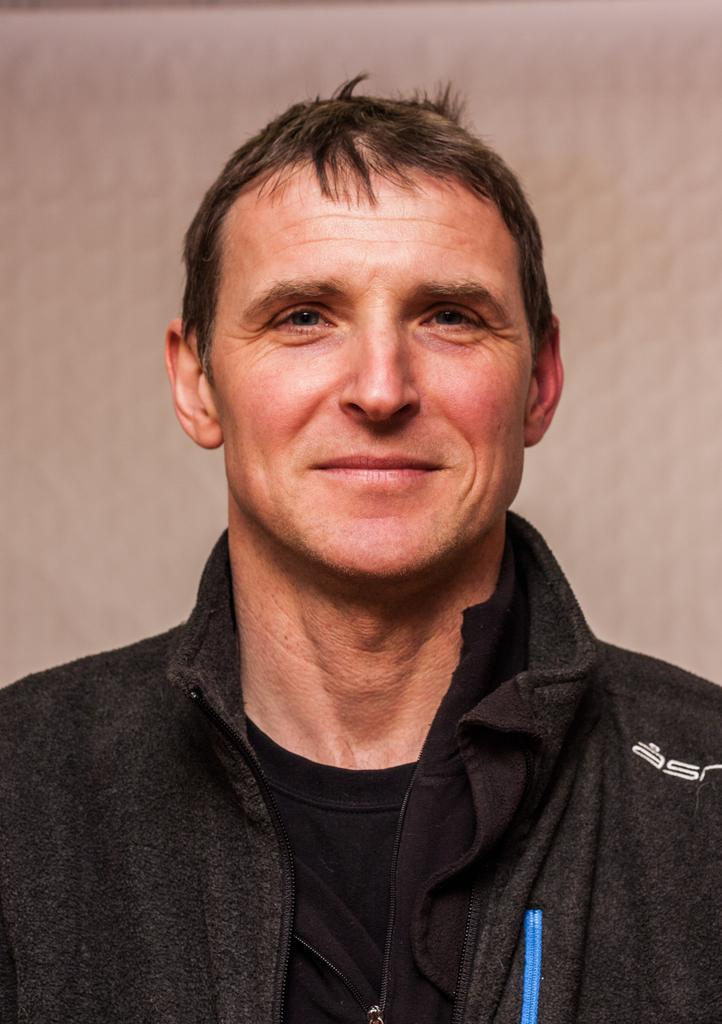Who is present in the image? There is a man in the picture. What is the man wearing? The man is wearing a black jacket. What is the man's facial expression? The man is smiling. What color is the background of the picture? The background of the picture is in cream color. How does the man lead the group of firefighters in the image? There are no firefighters or any indication of a group in the image. The man is simply smiling, and wearing a black jacket in front of a cream-colored background. 